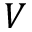<formula> <loc_0><loc_0><loc_500><loc_500>V</formula> 